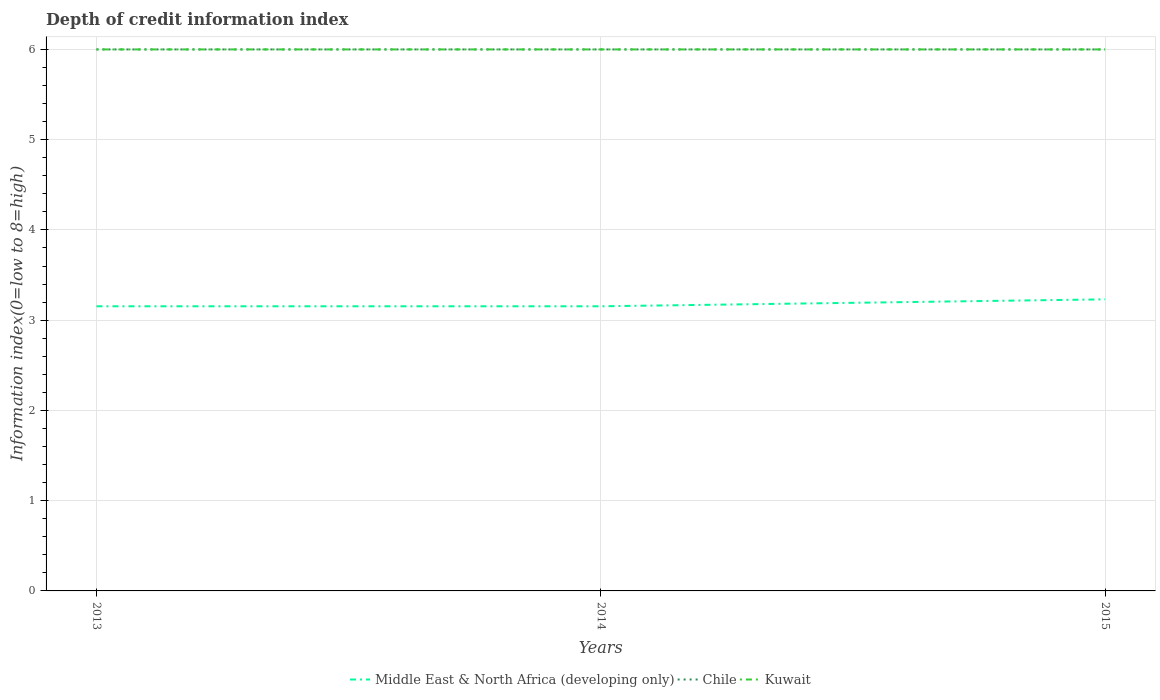What is the total information index in Middle East & North Africa (developing only) in the graph?
Offer a very short reply. -0.08. What is the difference between the highest and the second highest information index in Middle East & North Africa (developing only)?
Provide a short and direct response. 0.08. What is the difference between the highest and the lowest information index in Kuwait?
Offer a very short reply. 0. Is the information index in Chile strictly greater than the information index in Kuwait over the years?
Provide a short and direct response. No. How many years are there in the graph?
Your answer should be compact. 3. Are the values on the major ticks of Y-axis written in scientific E-notation?
Provide a short and direct response. No. Does the graph contain grids?
Your response must be concise. Yes. How many legend labels are there?
Offer a very short reply. 3. How are the legend labels stacked?
Offer a terse response. Horizontal. What is the title of the graph?
Offer a terse response. Depth of credit information index. Does "Nigeria" appear as one of the legend labels in the graph?
Keep it short and to the point. No. What is the label or title of the X-axis?
Provide a succinct answer. Years. What is the label or title of the Y-axis?
Provide a short and direct response. Information index(0=low to 8=high). What is the Information index(0=low to 8=high) in Middle East & North Africa (developing only) in 2013?
Keep it short and to the point. 3.15. What is the Information index(0=low to 8=high) in Middle East & North Africa (developing only) in 2014?
Your answer should be compact. 3.15. What is the Information index(0=low to 8=high) in Kuwait in 2014?
Make the answer very short. 6. What is the Information index(0=low to 8=high) in Middle East & North Africa (developing only) in 2015?
Ensure brevity in your answer.  3.23. What is the Information index(0=low to 8=high) of Kuwait in 2015?
Your answer should be compact. 6. Across all years, what is the maximum Information index(0=low to 8=high) of Middle East & North Africa (developing only)?
Make the answer very short. 3.23. Across all years, what is the maximum Information index(0=low to 8=high) of Kuwait?
Give a very brief answer. 6. Across all years, what is the minimum Information index(0=low to 8=high) in Middle East & North Africa (developing only)?
Give a very brief answer. 3.15. Across all years, what is the minimum Information index(0=low to 8=high) of Chile?
Give a very brief answer. 6. Across all years, what is the minimum Information index(0=low to 8=high) of Kuwait?
Your answer should be compact. 6. What is the total Information index(0=low to 8=high) in Middle East & North Africa (developing only) in the graph?
Give a very brief answer. 9.54. What is the total Information index(0=low to 8=high) in Chile in the graph?
Your answer should be very brief. 18. What is the total Information index(0=low to 8=high) in Kuwait in the graph?
Provide a succinct answer. 18. What is the difference between the Information index(0=low to 8=high) in Chile in 2013 and that in 2014?
Offer a terse response. 0. What is the difference between the Information index(0=low to 8=high) of Kuwait in 2013 and that in 2014?
Offer a very short reply. 0. What is the difference between the Information index(0=low to 8=high) of Middle East & North Africa (developing only) in 2013 and that in 2015?
Your response must be concise. -0.08. What is the difference between the Information index(0=low to 8=high) of Chile in 2013 and that in 2015?
Your answer should be compact. 0. What is the difference between the Information index(0=low to 8=high) in Kuwait in 2013 and that in 2015?
Offer a terse response. 0. What is the difference between the Information index(0=low to 8=high) of Middle East & North Africa (developing only) in 2014 and that in 2015?
Give a very brief answer. -0.08. What is the difference between the Information index(0=low to 8=high) in Middle East & North Africa (developing only) in 2013 and the Information index(0=low to 8=high) in Chile in 2014?
Offer a very short reply. -2.85. What is the difference between the Information index(0=low to 8=high) in Middle East & North Africa (developing only) in 2013 and the Information index(0=low to 8=high) in Kuwait in 2014?
Your answer should be compact. -2.85. What is the difference between the Information index(0=low to 8=high) of Middle East & North Africa (developing only) in 2013 and the Information index(0=low to 8=high) of Chile in 2015?
Make the answer very short. -2.85. What is the difference between the Information index(0=low to 8=high) in Middle East & North Africa (developing only) in 2013 and the Information index(0=low to 8=high) in Kuwait in 2015?
Offer a very short reply. -2.85. What is the difference between the Information index(0=low to 8=high) in Middle East & North Africa (developing only) in 2014 and the Information index(0=low to 8=high) in Chile in 2015?
Keep it short and to the point. -2.85. What is the difference between the Information index(0=low to 8=high) of Middle East & North Africa (developing only) in 2014 and the Information index(0=low to 8=high) of Kuwait in 2015?
Provide a succinct answer. -2.85. What is the difference between the Information index(0=low to 8=high) of Chile in 2014 and the Information index(0=low to 8=high) of Kuwait in 2015?
Keep it short and to the point. 0. What is the average Information index(0=low to 8=high) in Middle East & North Africa (developing only) per year?
Your answer should be compact. 3.18. What is the average Information index(0=low to 8=high) in Kuwait per year?
Make the answer very short. 6. In the year 2013, what is the difference between the Information index(0=low to 8=high) in Middle East & North Africa (developing only) and Information index(0=low to 8=high) in Chile?
Your answer should be very brief. -2.85. In the year 2013, what is the difference between the Information index(0=low to 8=high) of Middle East & North Africa (developing only) and Information index(0=low to 8=high) of Kuwait?
Your answer should be very brief. -2.85. In the year 2013, what is the difference between the Information index(0=low to 8=high) of Chile and Information index(0=low to 8=high) of Kuwait?
Keep it short and to the point. 0. In the year 2014, what is the difference between the Information index(0=low to 8=high) of Middle East & North Africa (developing only) and Information index(0=low to 8=high) of Chile?
Make the answer very short. -2.85. In the year 2014, what is the difference between the Information index(0=low to 8=high) of Middle East & North Africa (developing only) and Information index(0=low to 8=high) of Kuwait?
Provide a short and direct response. -2.85. In the year 2014, what is the difference between the Information index(0=low to 8=high) of Chile and Information index(0=low to 8=high) of Kuwait?
Offer a very short reply. 0. In the year 2015, what is the difference between the Information index(0=low to 8=high) in Middle East & North Africa (developing only) and Information index(0=low to 8=high) in Chile?
Provide a succinct answer. -2.77. In the year 2015, what is the difference between the Information index(0=low to 8=high) in Middle East & North Africa (developing only) and Information index(0=low to 8=high) in Kuwait?
Your answer should be compact. -2.77. In the year 2015, what is the difference between the Information index(0=low to 8=high) of Chile and Information index(0=low to 8=high) of Kuwait?
Your answer should be compact. 0. What is the ratio of the Information index(0=low to 8=high) in Kuwait in 2013 to that in 2014?
Provide a short and direct response. 1. What is the ratio of the Information index(0=low to 8=high) of Middle East & North Africa (developing only) in 2013 to that in 2015?
Offer a very short reply. 0.98. What is the ratio of the Information index(0=low to 8=high) of Middle East & North Africa (developing only) in 2014 to that in 2015?
Offer a very short reply. 0.98. What is the ratio of the Information index(0=low to 8=high) of Kuwait in 2014 to that in 2015?
Provide a succinct answer. 1. What is the difference between the highest and the second highest Information index(0=low to 8=high) of Middle East & North Africa (developing only)?
Ensure brevity in your answer.  0.08. What is the difference between the highest and the second highest Information index(0=low to 8=high) of Kuwait?
Provide a succinct answer. 0. What is the difference between the highest and the lowest Information index(0=low to 8=high) of Middle East & North Africa (developing only)?
Offer a very short reply. 0.08. What is the difference between the highest and the lowest Information index(0=low to 8=high) of Kuwait?
Make the answer very short. 0. 